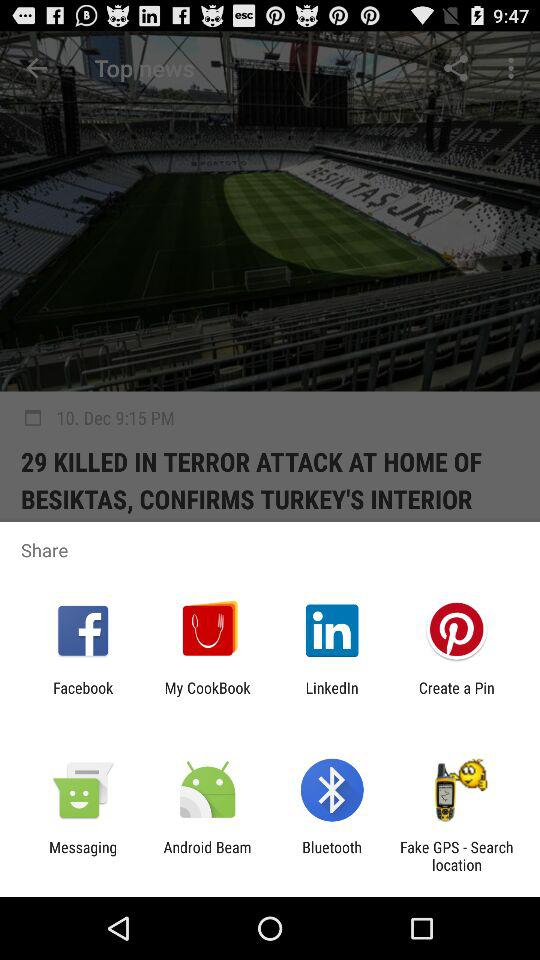On what date was the article published? The article was published on December 10. 